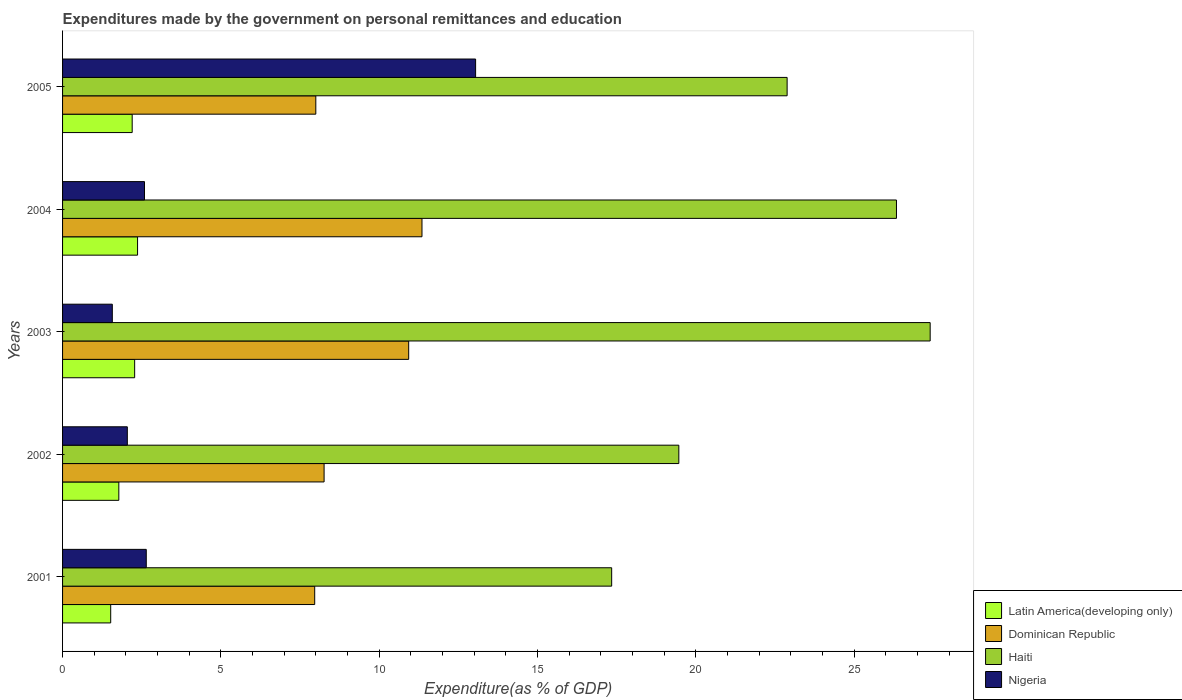How many different coloured bars are there?
Keep it short and to the point. 4. How many bars are there on the 1st tick from the bottom?
Offer a terse response. 4. What is the expenditures made by the government on personal remittances and education in Nigeria in 2001?
Offer a very short reply. 2.64. Across all years, what is the maximum expenditures made by the government on personal remittances and education in Dominican Republic?
Your answer should be compact. 11.35. Across all years, what is the minimum expenditures made by the government on personal remittances and education in Dominican Republic?
Give a very brief answer. 7.96. In which year was the expenditures made by the government on personal remittances and education in Nigeria maximum?
Ensure brevity in your answer.  2005. What is the total expenditures made by the government on personal remittances and education in Nigeria in the graph?
Your response must be concise. 21.89. What is the difference between the expenditures made by the government on personal remittances and education in Nigeria in 2001 and that in 2002?
Offer a terse response. 0.6. What is the difference between the expenditures made by the government on personal remittances and education in Latin America(developing only) in 2004 and the expenditures made by the government on personal remittances and education in Haiti in 2002?
Keep it short and to the point. -17.09. What is the average expenditures made by the government on personal remittances and education in Latin America(developing only) per year?
Your answer should be compact. 2.03. In the year 2001, what is the difference between the expenditures made by the government on personal remittances and education in Haiti and expenditures made by the government on personal remittances and education in Dominican Republic?
Provide a short and direct response. 9.38. In how many years, is the expenditures made by the government on personal remittances and education in Latin America(developing only) greater than 10 %?
Your answer should be compact. 0. What is the ratio of the expenditures made by the government on personal remittances and education in Haiti in 2003 to that in 2004?
Ensure brevity in your answer.  1.04. Is the expenditures made by the government on personal remittances and education in Nigeria in 2004 less than that in 2005?
Provide a short and direct response. Yes. What is the difference between the highest and the second highest expenditures made by the government on personal remittances and education in Latin America(developing only)?
Make the answer very short. 0.09. What is the difference between the highest and the lowest expenditures made by the government on personal remittances and education in Nigeria?
Your answer should be very brief. 11.47. Is the sum of the expenditures made by the government on personal remittances and education in Haiti in 2003 and 2005 greater than the maximum expenditures made by the government on personal remittances and education in Dominican Republic across all years?
Provide a short and direct response. Yes. Is it the case that in every year, the sum of the expenditures made by the government on personal remittances and education in Nigeria and expenditures made by the government on personal remittances and education in Latin America(developing only) is greater than the sum of expenditures made by the government on personal remittances and education in Dominican Republic and expenditures made by the government on personal remittances and education in Haiti?
Your answer should be compact. No. What does the 2nd bar from the top in 2001 represents?
Offer a terse response. Haiti. What does the 2nd bar from the bottom in 2001 represents?
Keep it short and to the point. Dominican Republic. Is it the case that in every year, the sum of the expenditures made by the government on personal remittances and education in Haiti and expenditures made by the government on personal remittances and education in Latin America(developing only) is greater than the expenditures made by the government on personal remittances and education in Dominican Republic?
Give a very brief answer. Yes. How many bars are there?
Offer a terse response. 20. Are the values on the major ticks of X-axis written in scientific E-notation?
Offer a very short reply. No. Does the graph contain any zero values?
Provide a short and direct response. No. Where does the legend appear in the graph?
Your answer should be very brief. Bottom right. How many legend labels are there?
Your response must be concise. 4. How are the legend labels stacked?
Provide a short and direct response. Vertical. What is the title of the graph?
Make the answer very short. Expenditures made by the government on personal remittances and education. Does "Central Europe" appear as one of the legend labels in the graph?
Give a very brief answer. No. What is the label or title of the X-axis?
Offer a terse response. Expenditure(as % of GDP). What is the Expenditure(as % of GDP) of Latin America(developing only) in 2001?
Ensure brevity in your answer.  1.52. What is the Expenditure(as % of GDP) of Dominican Republic in 2001?
Your answer should be compact. 7.96. What is the Expenditure(as % of GDP) in Haiti in 2001?
Provide a succinct answer. 17.34. What is the Expenditure(as % of GDP) in Nigeria in 2001?
Your answer should be compact. 2.64. What is the Expenditure(as % of GDP) of Latin America(developing only) in 2002?
Your answer should be compact. 1.78. What is the Expenditure(as % of GDP) of Dominican Republic in 2002?
Make the answer very short. 8.26. What is the Expenditure(as % of GDP) in Haiti in 2002?
Keep it short and to the point. 19.46. What is the Expenditure(as % of GDP) of Nigeria in 2002?
Your response must be concise. 2.04. What is the Expenditure(as % of GDP) in Latin America(developing only) in 2003?
Give a very brief answer. 2.28. What is the Expenditure(as % of GDP) in Dominican Republic in 2003?
Ensure brevity in your answer.  10.93. What is the Expenditure(as % of GDP) in Haiti in 2003?
Your answer should be compact. 27.4. What is the Expenditure(as % of GDP) of Nigeria in 2003?
Ensure brevity in your answer.  1.57. What is the Expenditure(as % of GDP) in Latin America(developing only) in 2004?
Give a very brief answer. 2.37. What is the Expenditure(as % of GDP) of Dominican Republic in 2004?
Provide a succinct answer. 11.35. What is the Expenditure(as % of GDP) in Haiti in 2004?
Your answer should be very brief. 26.33. What is the Expenditure(as % of GDP) in Nigeria in 2004?
Give a very brief answer. 2.59. What is the Expenditure(as % of GDP) in Latin America(developing only) in 2005?
Your response must be concise. 2.2. What is the Expenditure(as % of GDP) of Dominican Republic in 2005?
Offer a terse response. 8. What is the Expenditure(as % of GDP) in Haiti in 2005?
Offer a terse response. 22.88. What is the Expenditure(as % of GDP) of Nigeria in 2005?
Offer a very short reply. 13.04. Across all years, what is the maximum Expenditure(as % of GDP) in Latin America(developing only)?
Provide a short and direct response. 2.37. Across all years, what is the maximum Expenditure(as % of GDP) of Dominican Republic?
Your answer should be very brief. 11.35. Across all years, what is the maximum Expenditure(as % of GDP) of Haiti?
Make the answer very short. 27.4. Across all years, what is the maximum Expenditure(as % of GDP) of Nigeria?
Provide a succinct answer. 13.04. Across all years, what is the minimum Expenditure(as % of GDP) in Latin America(developing only)?
Offer a very short reply. 1.52. Across all years, what is the minimum Expenditure(as % of GDP) of Dominican Republic?
Keep it short and to the point. 7.96. Across all years, what is the minimum Expenditure(as % of GDP) of Haiti?
Give a very brief answer. 17.34. Across all years, what is the minimum Expenditure(as % of GDP) in Nigeria?
Offer a very short reply. 1.57. What is the total Expenditure(as % of GDP) of Latin America(developing only) in the graph?
Provide a short and direct response. 10.14. What is the total Expenditure(as % of GDP) in Dominican Republic in the graph?
Your response must be concise. 46.49. What is the total Expenditure(as % of GDP) in Haiti in the graph?
Give a very brief answer. 113.4. What is the total Expenditure(as % of GDP) of Nigeria in the graph?
Provide a short and direct response. 21.89. What is the difference between the Expenditure(as % of GDP) in Latin America(developing only) in 2001 and that in 2002?
Ensure brevity in your answer.  -0.26. What is the difference between the Expenditure(as % of GDP) of Dominican Republic in 2001 and that in 2002?
Your response must be concise. -0.3. What is the difference between the Expenditure(as % of GDP) in Haiti in 2001 and that in 2002?
Give a very brief answer. -2.12. What is the difference between the Expenditure(as % of GDP) of Nigeria in 2001 and that in 2002?
Give a very brief answer. 0.6. What is the difference between the Expenditure(as % of GDP) of Latin America(developing only) in 2001 and that in 2003?
Your answer should be very brief. -0.76. What is the difference between the Expenditure(as % of GDP) of Dominican Republic in 2001 and that in 2003?
Your answer should be very brief. -2.97. What is the difference between the Expenditure(as % of GDP) of Haiti in 2001 and that in 2003?
Your answer should be compact. -10.06. What is the difference between the Expenditure(as % of GDP) in Nigeria in 2001 and that in 2003?
Your response must be concise. 1.07. What is the difference between the Expenditure(as % of GDP) in Latin America(developing only) in 2001 and that in 2004?
Provide a short and direct response. -0.85. What is the difference between the Expenditure(as % of GDP) in Dominican Republic in 2001 and that in 2004?
Offer a very short reply. -3.39. What is the difference between the Expenditure(as % of GDP) in Haiti in 2001 and that in 2004?
Offer a terse response. -8.99. What is the difference between the Expenditure(as % of GDP) of Nigeria in 2001 and that in 2004?
Make the answer very short. 0.06. What is the difference between the Expenditure(as % of GDP) in Latin America(developing only) in 2001 and that in 2005?
Your answer should be compact. -0.68. What is the difference between the Expenditure(as % of GDP) in Dominican Republic in 2001 and that in 2005?
Make the answer very short. -0.04. What is the difference between the Expenditure(as % of GDP) in Haiti in 2001 and that in 2005?
Make the answer very short. -5.54. What is the difference between the Expenditure(as % of GDP) in Nigeria in 2001 and that in 2005?
Your response must be concise. -10.4. What is the difference between the Expenditure(as % of GDP) in Latin America(developing only) in 2002 and that in 2003?
Ensure brevity in your answer.  -0.5. What is the difference between the Expenditure(as % of GDP) of Dominican Republic in 2002 and that in 2003?
Your response must be concise. -2.67. What is the difference between the Expenditure(as % of GDP) of Haiti in 2002 and that in 2003?
Make the answer very short. -7.94. What is the difference between the Expenditure(as % of GDP) in Nigeria in 2002 and that in 2003?
Your answer should be compact. 0.47. What is the difference between the Expenditure(as % of GDP) of Latin America(developing only) in 2002 and that in 2004?
Keep it short and to the point. -0.59. What is the difference between the Expenditure(as % of GDP) of Dominican Republic in 2002 and that in 2004?
Keep it short and to the point. -3.09. What is the difference between the Expenditure(as % of GDP) in Haiti in 2002 and that in 2004?
Provide a succinct answer. -6.87. What is the difference between the Expenditure(as % of GDP) of Nigeria in 2002 and that in 2004?
Ensure brevity in your answer.  -0.54. What is the difference between the Expenditure(as % of GDP) of Latin America(developing only) in 2002 and that in 2005?
Keep it short and to the point. -0.42. What is the difference between the Expenditure(as % of GDP) in Dominican Republic in 2002 and that in 2005?
Your answer should be compact. 0.26. What is the difference between the Expenditure(as % of GDP) of Haiti in 2002 and that in 2005?
Your answer should be compact. -3.42. What is the difference between the Expenditure(as % of GDP) in Nigeria in 2002 and that in 2005?
Ensure brevity in your answer.  -11. What is the difference between the Expenditure(as % of GDP) of Latin America(developing only) in 2003 and that in 2004?
Provide a short and direct response. -0.09. What is the difference between the Expenditure(as % of GDP) in Dominican Republic in 2003 and that in 2004?
Offer a very short reply. -0.42. What is the difference between the Expenditure(as % of GDP) of Haiti in 2003 and that in 2004?
Your answer should be compact. 1.06. What is the difference between the Expenditure(as % of GDP) in Nigeria in 2003 and that in 2004?
Give a very brief answer. -1.02. What is the difference between the Expenditure(as % of GDP) in Latin America(developing only) in 2003 and that in 2005?
Your answer should be compact. 0.08. What is the difference between the Expenditure(as % of GDP) in Dominican Republic in 2003 and that in 2005?
Provide a succinct answer. 2.93. What is the difference between the Expenditure(as % of GDP) in Haiti in 2003 and that in 2005?
Offer a very short reply. 4.52. What is the difference between the Expenditure(as % of GDP) of Nigeria in 2003 and that in 2005?
Provide a succinct answer. -11.47. What is the difference between the Expenditure(as % of GDP) of Latin America(developing only) in 2004 and that in 2005?
Offer a terse response. 0.17. What is the difference between the Expenditure(as % of GDP) of Dominican Republic in 2004 and that in 2005?
Provide a short and direct response. 3.35. What is the difference between the Expenditure(as % of GDP) in Haiti in 2004 and that in 2005?
Ensure brevity in your answer.  3.45. What is the difference between the Expenditure(as % of GDP) of Nigeria in 2004 and that in 2005?
Your response must be concise. -10.46. What is the difference between the Expenditure(as % of GDP) in Latin America(developing only) in 2001 and the Expenditure(as % of GDP) in Dominican Republic in 2002?
Ensure brevity in your answer.  -6.74. What is the difference between the Expenditure(as % of GDP) of Latin America(developing only) in 2001 and the Expenditure(as % of GDP) of Haiti in 2002?
Ensure brevity in your answer.  -17.94. What is the difference between the Expenditure(as % of GDP) in Latin America(developing only) in 2001 and the Expenditure(as % of GDP) in Nigeria in 2002?
Your response must be concise. -0.52. What is the difference between the Expenditure(as % of GDP) in Dominican Republic in 2001 and the Expenditure(as % of GDP) in Haiti in 2002?
Give a very brief answer. -11.5. What is the difference between the Expenditure(as % of GDP) of Dominican Republic in 2001 and the Expenditure(as % of GDP) of Nigeria in 2002?
Provide a succinct answer. 5.92. What is the difference between the Expenditure(as % of GDP) of Haiti in 2001 and the Expenditure(as % of GDP) of Nigeria in 2002?
Ensure brevity in your answer.  15.29. What is the difference between the Expenditure(as % of GDP) of Latin America(developing only) in 2001 and the Expenditure(as % of GDP) of Dominican Republic in 2003?
Ensure brevity in your answer.  -9.41. What is the difference between the Expenditure(as % of GDP) in Latin America(developing only) in 2001 and the Expenditure(as % of GDP) in Haiti in 2003?
Keep it short and to the point. -25.88. What is the difference between the Expenditure(as % of GDP) in Latin America(developing only) in 2001 and the Expenditure(as % of GDP) in Nigeria in 2003?
Ensure brevity in your answer.  -0.05. What is the difference between the Expenditure(as % of GDP) of Dominican Republic in 2001 and the Expenditure(as % of GDP) of Haiti in 2003?
Ensure brevity in your answer.  -19.43. What is the difference between the Expenditure(as % of GDP) of Dominican Republic in 2001 and the Expenditure(as % of GDP) of Nigeria in 2003?
Offer a terse response. 6.39. What is the difference between the Expenditure(as % of GDP) of Haiti in 2001 and the Expenditure(as % of GDP) of Nigeria in 2003?
Your response must be concise. 15.77. What is the difference between the Expenditure(as % of GDP) of Latin America(developing only) in 2001 and the Expenditure(as % of GDP) of Dominican Republic in 2004?
Your answer should be very brief. -9.83. What is the difference between the Expenditure(as % of GDP) in Latin America(developing only) in 2001 and the Expenditure(as % of GDP) in Haiti in 2004?
Your answer should be compact. -24.81. What is the difference between the Expenditure(as % of GDP) of Latin America(developing only) in 2001 and the Expenditure(as % of GDP) of Nigeria in 2004?
Ensure brevity in your answer.  -1.07. What is the difference between the Expenditure(as % of GDP) in Dominican Republic in 2001 and the Expenditure(as % of GDP) in Haiti in 2004?
Your response must be concise. -18.37. What is the difference between the Expenditure(as % of GDP) of Dominican Republic in 2001 and the Expenditure(as % of GDP) of Nigeria in 2004?
Offer a terse response. 5.37. What is the difference between the Expenditure(as % of GDP) in Haiti in 2001 and the Expenditure(as % of GDP) in Nigeria in 2004?
Keep it short and to the point. 14.75. What is the difference between the Expenditure(as % of GDP) of Latin America(developing only) in 2001 and the Expenditure(as % of GDP) of Dominican Republic in 2005?
Ensure brevity in your answer.  -6.48. What is the difference between the Expenditure(as % of GDP) in Latin America(developing only) in 2001 and the Expenditure(as % of GDP) in Haiti in 2005?
Offer a very short reply. -21.36. What is the difference between the Expenditure(as % of GDP) in Latin America(developing only) in 2001 and the Expenditure(as % of GDP) in Nigeria in 2005?
Your answer should be very brief. -11.52. What is the difference between the Expenditure(as % of GDP) of Dominican Republic in 2001 and the Expenditure(as % of GDP) of Haiti in 2005?
Offer a terse response. -14.92. What is the difference between the Expenditure(as % of GDP) in Dominican Republic in 2001 and the Expenditure(as % of GDP) in Nigeria in 2005?
Your answer should be very brief. -5.08. What is the difference between the Expenditure(as % of GDP) in Haiti in 2001 and the Expenditure(as % of GDP) in Nigeria in 2005?
Your answer should be compact. 4.3. What is the difference between the Expenditure(as % of GDP) of Latin America(developing only) in 2002 and the Expenditure(as % of GDP) of Dominican Republic in 2003?
Provide a short and direct response. -9.15. What is the difference between the Expenditure(as % of GDP) in Latin America(developing only) in 2002 and the Expenditure(as % of GDP) in Haiti in 2003?
Keep it short and to the point. -25.62. What is the difference between the Expenditure(as % of GDP) of Latin America(developing only) in 2002 and the Expenditure(as % of GDP) of Nigeria in 2003?
Keep it short and to the point. 0.21. What is the difference between the Expenditure(as % of GDP) of Dominican Republic in 2002 and the Expenditure(as % of GDP) of Haiti in 2003?
Your response must be concise. -19.14. What is the difference between the Expenditure(as % of GDP) in Dominican Republic in 2002 and the Expenditure(as % of GDP) in Nigeria in 2003?
Give a very brief answer. 6.69. What is the difference between the Expenditure(as % of GDP) of Haiti in 2002 and the Expenditure(as % of GDP) of Nigeria in 2003?
Your response must be concise. 17.89. What is the difference between the Expenditure(as % of GDP) of Latin America(developing only) in 2002 and the Expenditure(as % of GDP) of Dominican Republic in 2004?
Provide a succinct answer. -9.57. What is the difference between the Expenditure(as % of GDP) of Latin America(developing only) in 2002 and the Expenditure(as % of GDP) of Haiti in 2004?
Provide a succinct answer. -24.56. What is the difference between the Expenditure(as % of GDP) in Latin America(developing only) in 2002 and the Expenditure(as % of GDP) in Nigeria in 2004?
Your answer should be very brief. -0.81. What is the difference between the Expenditure(as % of GDP) in Dominican Republic in 2002 and the Expenditure(as % of GDP) in Haiti in 2004?
Give a very brief answer. -18.07. What is the difference between the Expenditure(as % of GDP) of Dominican Republic in 2002 and the Expenditure(as % of GDP) of Nigeria in 2004?
Offer a very short reply. 5.67. What is the difference between the Expenditure(as % of GDP) in Haiti in 2002 and the Expenditure(as % of GDP) in Nigeria in 2004?
Provide a short and direct response. 16.87. What is the difference between the Expenditure(as % of GDP) in Latin America(developing only) in 2002 and the Expenditure(as % of GDP) in Dominican Republic in 2005?
Offer a terse response. -6.22. What is the difference between the Expenditure(as % of GDP) of Latin America(developing only) in 2002 and the Expenditure(as % of GDP) of Haiti in 2005?
Ensure brevity in your answer.  -21.1. What is the difference between the Expenditure(as % of GDP) in Latin America(developing only) in 2002 and the Expenditure(as % of GDP) in Nigeria in 2005?
Keep it short and to the point. -11.27. What is the difference between the Expenditure(as % of GDP) in Dominican Republic in 2002 and the Expenditure(as % of GDP) in Haiti in 2005?
Your answer should be very brief. -14.62. What is the difference between the Expenditure(as % of GDP) of Dominican Republic in 2002 and the Expenditure(as % of GDP) of Nigeria in 2005?
Your answer should be very brief. -4.78. What is the difference between the Expenditure(as % of GDP) in Haiti in 2002 and the Expenditure(as % of GDP) in Nigeria in 2005?
Your response must be concise. 6.42. What is the difference between the Expenditure(as % of GDP) in Latin America(developing only) in 2003 and the Expenditure(as % of GDP) in Dominican Republic in 2004?
Keep it short and to the point. -9.07. What is the difference between the Expenditure(as % of GDP) in Latin America(developing only) in 2003 and the Expenditure(as % of GDP) in Haiti in 2004?
Your answer should be very brief. -24.06. What is the difference between the Expenditure(as % of GDP) in Latin America(developing only) in 2003 and the Expenditure(as % of GDP) in Nigeria in 2004?
Provide a succinct answer. -0.31. What is the difference between the Expenditure(as % of GDP) in Dominican Republic in 2003 and the Expenditure(as % of GDP) in Haiti in 2004?
Your answer should be compact. -15.4. What is the difference between the Expenditure(as % of GDP) in Dominican Republic in 2003 and the Expenditure(as % of GDP) in Nigeria in 2004?
Provide a short and direct response. 8.34. What is the difference between the Expenditure(as % of GDP) of Haiti in 2003 and the Expenditure(as % of GDP) of Nigeria in 2004?
Offer a very short reply. 24.81. What is the difference between the Expenditure(as % of GDP) in Latin America(developing only) in 2003 and the Expenditure(as % of GDP) in Dominican Republic in 2005?
Your answer should be very brief. -5.72. What is the difference between the Expenditure(as % of GDP) of Latin America(developing only) in 2003 and the Expenditure(as % of GDP) of Haiti in 2005?
Keep it short and to the point. -20.6. What is the difference between the Expenditure(as % of GDP) in Latin America(developing only) in 2003 and the Expenditure(as % of GDP) in Nigeria in 2005?
Offer a very short reply. -10.77. What is the difference between the Expenditure(as % of GDP) in Dominican Republic in 2003 and the Expenditure(as % of GDP) in Haiti in 2005?
Offer a very short reply. -11.95. What is the difference between the Expenditure(as % of GDP) of Dominican Republic in 2003 and the Expenditure(as % of GDP) of Nigeria in 2005?
Offer a very short reply. -2.11. What is the difference between the Expenditure(as % of GDP) in Haiti in 2003 and the Expenditure(as % of GDP) in Nigeria in 2005?
Offer a very short reply. 14.35. What is the difference between the Expenditure(as % of GDP) in Latin America(developing only) in 2004 and the Expenditure(as % of GDP) in Dominican Republic in 2005?
Ensure brevity in your answer.  -5.63. What is the difference between the Expenditure(as % of GDP) of Latin America(developing only) in 2004 and the Expenditure(as % of GDP) of Haiti in 2005?
Ensure brevity in your answer.  -20.51. What is the difference between the Expenditure(as % of GDP) of Latin America(developing only) in 2004 and the Expenditure(as % of GDP) of Nigeria in 2005?
Keep it short and to the point. -10.67. What is the difference between the Expenditure(as % of GDP) of Dominican Republic in 2004 and the Expenditure(as % of GDP) of Haiti in 2005?
Your answer should be compact. -11.53. What is the difference between the Expenditure(as % of GDP) of Dominican Republic in 2004 and the Expenditure(as % of GDP) of Nigeria in 2005?
Keep it short and to the point. -1.69. What is the difference between the Expenditure(as % of GDP) in Haiti in 2004 and the Expenditure(as % of GDP) in Nigeria in 2005?
Your answer should be very brief. 13.29. What is the average Expenditure(as % of GDP) of Latin America(developing only) per year?
Provide a short and direct response. 2.03. What is the average Expenditure(as % of GDP) of Dominican Republic per year?
Ensure brevity in your answer.  9.3. What is the average Expenditure(as % of GDP) of Haiti per year?
Give a very brief answer. 22.68. What is the average Expenditure(as % of GDP) in Nigeria per year?
Provide a short and direct response. 4.38. In the year 2001, what is the difference between the Expenditure(as % of GDP) of Latin America(developing only) and Expenditure(as % of GDP) of Dominican Republic?
Provide a short and direct response. -6.44. In the year 2001, what is the difference between the Expenditure(as % of GDP) of Latin America(developing only) and Expenditure(as % of GDP) of Haiti?
Your response must be concise. -15.82. In the year 2001, what is the difference between the Expenditure(as % of GDP) in Latin America(developing only) and Expenditure(as % of GDP) in Nigeria?
Keep it short and to the point. -1.12. In the year 2001, what is the difference between the Expenditure(as % of GDP) of Dominican Republic and Expenditure(as % of GDP) of Haiti?
Offer a terse response. -9.38. In the year 2001, what is the difference between the Expenditure(as % of GDP) of Dominican Republic and Expenditure(as % of GDP) of Nigeria?
Give a very brief answer. 5.32. In the year 2001, what is the difference between the Expenditure(as % of GDP) in Haiti and Expenditure(as % of GDP) in Nigeria?
Your answer should be very brief. 14.7. In the year 2002, what is the difference between the Expenditure(as % of GDP) of Latin America(developing only) and Expenditure(as % of GDP) of Dominican Republic?
Offer a terse response. -6.48. In the year 2002, what is the difference between the Expenditure(as % of GDP) of Latin America(developing only) and Expenditure(as % of GDP) of Haiti?
Your answer should be compact. -17.68. In the year 2002, what is the difference between the Expenditure(as % of GDP) in Latin America(developing only) and Expenditure(as % of GDP) in Nigeria?
Give a very brief answer. -0.27. In the year 2002, what is the difference between the Expenditure(as % of GDP) in Dominican Republic and Expenditure(as % of GDP) in Haiti?
Provide a succinct answer. -11.2. In the year 2002, what is the difference between the Expenditure(as % of GDP) of Dominican Republic and Expenditure(as % of GDP) of Nigeria?
Your answer should be compact. 6.21. In the year 2002, what is the difference between the Expenditure(as % of GDP) of Haiti and Expenditure(as % of GDP) of Nigeria?
Your response must be concise. 17.41. In the year 2003, what is the difference between the Expenditure(as % of GDP) in Latin America(developing only) and Expenditure(as % of GDP) in Dominican Republic?
Your answer should be compact. -8.65. In the year 2003, what is the difference between the Expenditure(as % of GDP) in Latin America(developing only) and Expenditure(as % of GDP) in Haiti?
Give a very brief answer. -25.12. In the year 2003, what is the difference between the Expenditure(as % of GDP) in Latin America(developing only) and Expenditure(as % of GDP) in Nigeria?
Make the answer very short. 0.71. In the year 2003, what is the difference between the Expenditure(as % of GDP) of Dominican Republic and Expenditure(as % of GDP) of Haiti?
Make the answer very short. -16.47. In the year 2003, what is the difference between the Expenditure(as % of GDP) in Dominican Republic and Expenditure(as % of GDP) in Nigeria?
Offer a terse response. 9.36. In the year 2003, what is the difference between the Expenditure(as % of GDP) of Haiti and Expenditure(as % of GDP) of Nigeria?
Your answer should be compact. 25.82. In the year 2004, what is the difference between the Expenditure(as % of GDP) in Latin America(developing only) and Expenditure(as % of GDP) in Dominican Republic?
Your answer should be very brief. -8.98. In the year 2004, what is the difference between the Expenditure(as % of GDP) of Latin America(developing only) and Expenditure(as % of GDP) of Haiti?
Offer a very short reply. -23.96. In the year 2004, what is the difference between the Expenditure(as % of GDP) in Latin America(developing only) and Expenditure(as % of GDP) in Nigeria?
Keep it short and to the point. -0.22. In the year 2004, what is the difference between the Expenditure(as % of GDP) in Dominican Republic and Expenditure(as % of GDP) in Haiti?
Keep it short and to the point. -14.98. In the year 2004, what is the difference between the Expenditure(as % of GDP) in Dominican Republic and Expenditure(as % of GDP) in Nigeria?
Offer a very short reply. 8.76. In the year 2004, what is the difference between the Expenditure(as % of GDP) in Haiti and Expenditure(as % of GDP) in Nigeria?
Ensure brevity in your answer.  23.74. In the year 2005, what is the difference between the Expenditure(as % of GDP) in Latin America(developing only) and Expenditure(as % of GDP) in Dominican Republic?
Your response must be concise. -5.8. In the year 2005, what is the difference between the Expenditure(as % of GDP) of Latin America(developing only) and Expenditure(as % of GDP) of Haiti?
Offer a terse response. -20.68. In the year 2005, what is the difference between the Expenditure(as % of GDP) of Latin America(developing only) and Expenditure(as % of GDP) of Nigeria?
Offer a terse response. -10.84. In the year 2005, what is the difference between the Expenditure(as % of GDP) in Dominican Republic and Expenditure(as % of GDP) in Haiti?
Your answer should be compact. -14.88. In the year 2005, what is the difference between the Expenditure(as % of GDP) in Dominican Republic and Expenditure(as % of GDP) in Nigeria?
Ensure brevity in your answer.  -5.05. In the year 2005, what is the difference between the Expenditure(as % of GDP) in Haiti and Expenditure(as % of GDP) in Nigeria?
Offer a very short reply. 9.84. What is the ratio of the Expenditure(as % of GDP) in Latin America(developing only) in 2001 to that in 2002?
Your answer should be compact. 0.86. What is the ratio of the Expenditure(as % of GDP) of Dominican Republic in 2001 to that in 2002?
Offer a terse response. 0.96. What is the ratio of the Expenditure(as % of GDP) of Haiti in 2001 to that in 2002?
Your response must be concise. 0.89. What is the ratio of the Expenditure(as % of GDP) in Nigeria in 2001 to that in 2002?
Offer a terse response. 1.29. What is the ratio of the Expenditure(as % of GDP) in Latin America(developing only) in 2001 to that in 2003?
Keep it short and to the point. 0.67. What is the ratio of the Expenditure(as % of GDP) of Dominican Republic in 2001 to that in 2003?
Offer a terse response. 0.73. What is the ratio of the Expenditure(as % of GDP) in Haiti in 2001 to that in 2003?
Provide a short and direct response. 0.63. What is the ratio of the Expenditure(as % of GDP) of Nigeria in 2001 to that in 2003?
Provide a short and direct response. 1.68. What is the ratio of the Expenditure(as % of GDP) in Latin America(developing only) in 2001 to that in 2004?
Offer a terse response. 0.64. What is the ratio of the Expenditure(as % of GDP) of Dominican Republic in 2001 to that in 2004?
Provide a succinct answer. 0.7. What is the ratio of the Expenditure(as % of GDP) of Haiti in 2001 to that in 2004?
Keep it short and to the point. 0.66. What is the ratio of the Expenditure(as % of GDP) in Nigeria in 2001 to that in 2004?
Offer a very short reply. 1.02. What is the ratio of the Expenditure(as % of GDP) in Latin America(developing only) in 2001 to that in 2005?
Provide a succinct answer. 0.69. What is the ratio of the Expenditure(as % of GDP) in Haiti in 2001 to that in 2005?
Give a very brief answer. 0.76. What is the ratio of the Expenditure(as % of GDP) in Nigeria in 2001 to that in 2005?
Provide a short and direct response. 0.2. What is the ratio of the Expenditure(as % of GDP) of Latin America(developing only) in 2002 to that in 2003?
Provide a short and direct response. 0.78. What is the ratio of the Expenditure(as % of GDP) in Dominican Republic in 2002 to that in 2003?
Offer a terse response. 0.76. What is the ratio of the Expenditure(as % of GDP) in Haiti in 2002 to that in 2003?
Provide a succinct answer. 0.71. What is the ratio of the Expenditure(as % of GDP) of Nigeria in 2002 to that in 2003?
Offer a very short reply. 1.3. What is the ratio of the Expenditure(as % of GDP) in Latin America(developing only) in 2002 to that in 2004?
Offer a very short reply. 0.75. What is the ratio of the Expenditure(as % of GDP) of Dominican Republic in 2002 to that in 2004?
Provide a succinct answer. 0.73. What is the ratio of the Expenditure(as % of GDP) of Haiti in 2002 to that in 2004?
Your response must be concise. 0.74. What is the ratio of the Expenditure(as % of GDP) of Nigeria in 2002 to that in 2004?
Give a very brief answer. 0.79. What is the ratio of the Expenditure(as % of GDP) in Latin America(developing only) in 2002 to that in 2005?
Make the answer very short. 0.81. What is the ratio of the Expenditure(as % of GDP) in Dominican Republic in 2002 to that in 2005?
Ensure brevity in your answer.  1.03. What is the ratio of the Expenditure(as % of GDP) of Haiti in 2002 to that in 2005?
Give a very brief answer. 0.85. What is the ratio of the Expenditure(as % of GDP) in Nigeria in 2002 to that in 2005?
Make the answer very short. 0.16. What is the ratio of the Expenditure(as % of GDP) in Latin America(developing only) in 2003 to that in 2004?
Provide a succinct answer. 0.96. What is the ratio of the Expenditure(as % of GDP) in Dominican Republic in 2003 to that in 2004?
Your answer should be compact. 0.96. What is the ratio of the Expenditure(as % of GDP) of Haiti in 2003 to that in 2004?
Your answer should be very brief. 1.04. What is the ratio of the Expenditure(as % of GDP) in Nigeria in 2003 to that in 2004?
Make the answer very short. 0.61. What is the ratio of the Expenditure(as % of GDP) in Latin America(developing only) in 2003 to that in 2005?
Offer a terse response. 1.04. What is the ratio of the Expenditure(as % of GDP) of Dominican Republic in 2003 to that in 2005?
Provide a short and direct response. 1.37. What is the ratio of the Expenditure(as % of GDP) in Haiti in 2003 to that in 2005?
Keep it short and to the point. 1.2. What is the ratio of the Expenditure(as % of GDP) in Nigeria in 2003 to that in 2005?
Your answer should be very brief. 0.12. What is the ratio of the Expenditure(as % of GDP) of Latin America(developing only) in 2004 to that in 2005?
Your response must be concise. 1.08. What is the ratio of the Expenditure(as % of GDP) of Dominican Republic in 2004 to that in 2005?
Your response must be concise. 1.42. What is the ratio of the Expenditure(as % of GDP) of Haiti in 2004 to that in 2005?
Offer a terse response. 1.15. What is the ratio of the Expenditure(as % of GDP) in Nigeria in 2004 to that in 2005?
Offer a terse response. 0.2. What is the difference between the highest and the second highest Expenditure(as % of GDP) in Latin America(developing only)?
Keep it short and to the point. 0.09. What is the difference between the highest and the second highest Expenditure(as % of GDP) of Dominican Republic?
Provide a succinct answer. 0.42. What is the difference between the highest and the second highest Expenditure(as % of GDP) in Haiti?
Your answer should be compact. 1.06. What is the difference between the highest and the second highest Expenditure(as % of GDP) in Nigeria?
Make the answer very short. 10.4. What is the difference between the highest and the lowest Expenditure(as % of GDP) of Latin America(developing only)?
Keep it short and to the point. 0.85. What is the difference between the highest and the lowest Expenditure(as % of GDP) of Dominican Republic?
Keep it short and to the point. 3.39. What is the difference between the highest and the lowest Expenditure(as % of GDP) in Haiti?
Make the answer very short. 10.06. What is the difference between the highest and the lowest Expenditure(as % of GDP) of Nigeria?
Your response must be concise. 11.47. 